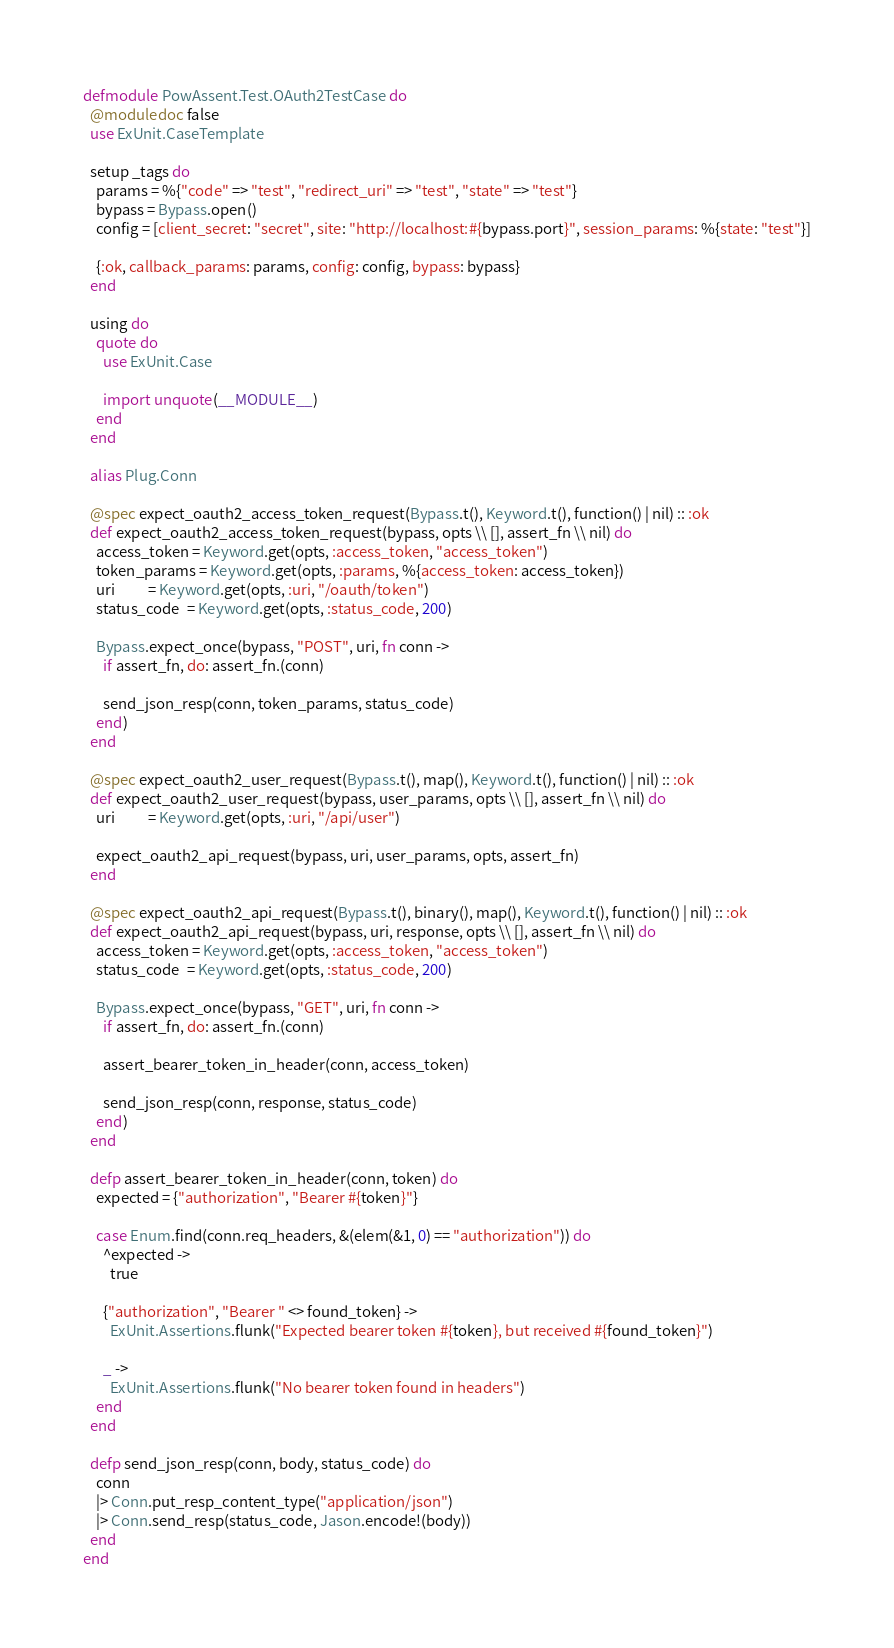Convert code to text. <code><loc_0><loc_0><loc_500><loc_500><_Elixir_>defmodule PowAssent.Test.OAuth2TestCase do
  @moduledoc false
  use ExUnit.CaseTemplate

  setup _tags do
    params = %{"code" => "test", "redirect_uri" => "test", "state" => "test"}
    bypass = Bypass.open()
    config = [client_secret: "secret", site: "http://localhost:#{bypass.port}", session_params: %{state: "test"}]

    {:ok, callback_params: params, config: config, bypass: bypass}
  end

  using do
    quote do
      use ExUnit.Case

      import unquote(__MODULE__)
    end
  end

  alias Plug.Conn

  @spec expect_oauth2_access_token_request(Bypass.t(), Keyword.t(), function() | nil) :: :ok
  def expect_oauth2_access_token_request(bypass, opts \\ [], assert_fn \\ nil) do
    access_token = Keyword.get(opts, :access_token, "access_token")
    token_params = Keyword.get(opts, :params, %{access_token: access_token})
    uri          = Keyword.get(opts, :uri, "/oauth/token")
    status_code  = Keyword.get(opts, :status_code, 200)

    Bypass.expect_once(bypass, "POST", uri, fn conn ->
      if assert_fn, do: assert_fn.(conn)

      send_json_resp(conn, token_params, status_code)
    end)
  end

  @spec expect_oauth2_user_request(Bypass.t(), map(), Keyword.t(), function() | nil) :: :ok
  def expect_oauth2_user_request(bypass, user_params, opts \\ [], assert_fn \\ nil) do
    uri          = Keyword.get(opts, :uri, "/api/user")

    expect_oauth2_api_request(bypass, uri, user_params, opts, assert_fn)
  end

  @spec expect_oauth2_api_request(Bypass.t(), binary(), map(), Keyword.t(), function() | nil) :: :ok
  def expect_oauth2_api_request(bypass, uri, response, opts \\ [], assert_fn \\ nil) do
    access_token = Keyword.get(opts, :access_token, "access_token")
    status_code  = Keyword.get(opts, :status_code, 200)

    Bypass.expect_once(bypass, "GET", uri, fn conn ->
      if assert_fn, do: assert_fn.(conn)

      assert_bearer_token_in_header(conn, access_token)

      send_json_resp(conn, response, status_code)
    end)
  end

  defp assert_bearer_token_in_header(conn, token) do
    expected = {"authorization", "Bearer #{token}"}

    case Enum.find(conn.req_headers, &(elem(&1, 0) == "authorization")) do
      ^expected ->
        true

      {"authorization", "Bearer " <> found_token} ->
        ExUnit.Assertions.flunk("Expected bearer token #{token}, but received #{found_token}")

      _ ->
        ExUnit.Assertions.flunk("No bearer token found in headers")
    end
  end

  defp send_json_resp(conn, body, status_code) do
    conn
    |> Conn.put_resp_content_type("application/json")
    |> Conn.send_resp(status_code, Jason.encode!(body))
  end
end
</code> 